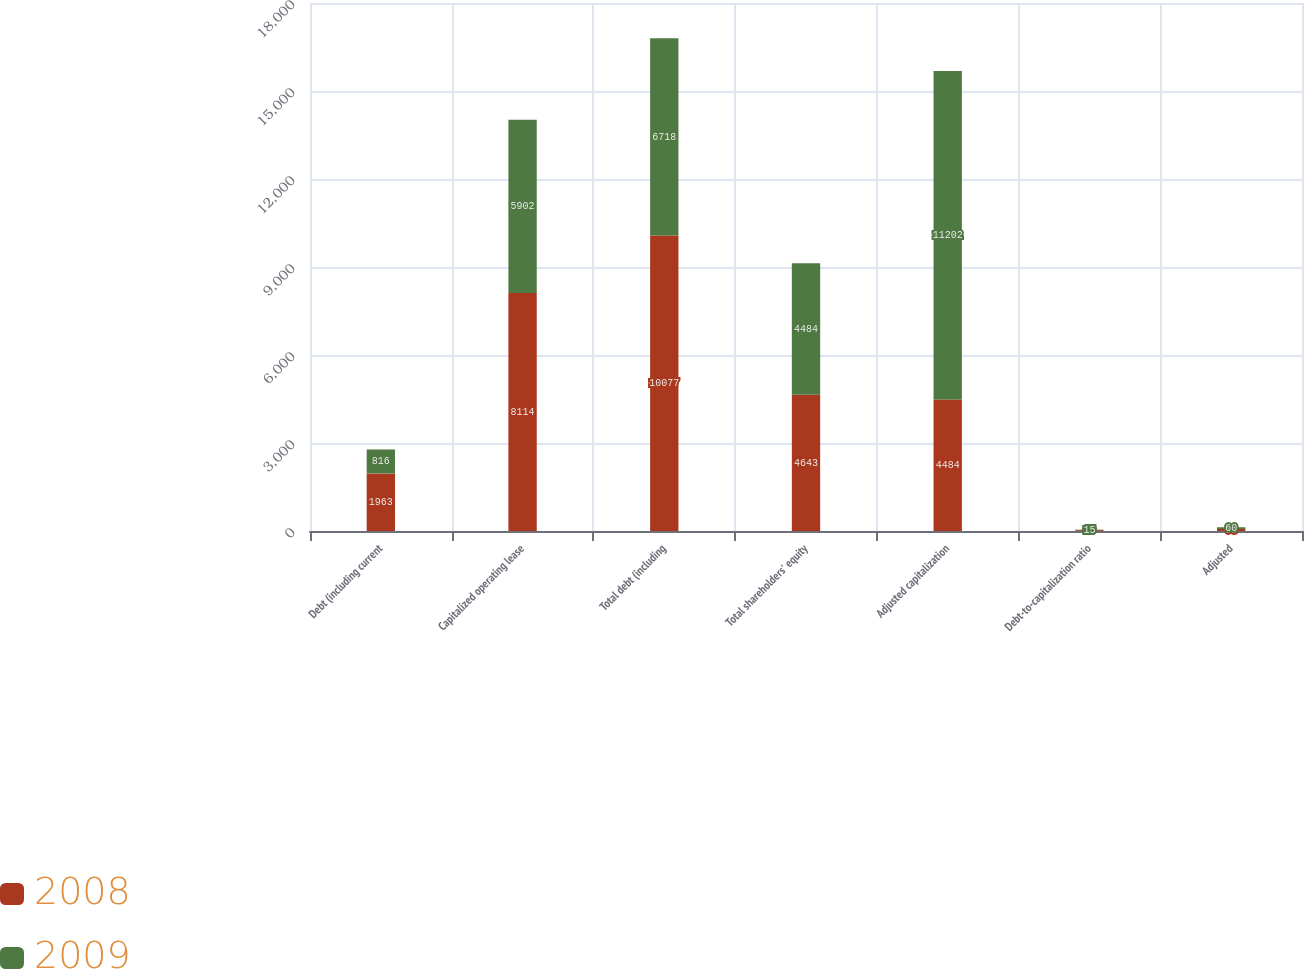Convert chart. <chart><loc_0><loc_0><loc_500><loc_500><stacked_bar_chart><ecel><fcel>Debt (including current<fcel>Capitalized operating lease<fcel>Total debt (including<fcel>Total shareholders' equity<fcel>Adjusted capitalization<fcel>Debt-to-capitalization ratio<fcel>Adjusted<nl><fcel>2008<fcel>1963<fcel>8114<fcel>10077<fcel>4643<fcel>4484<fcel>30<fcel>68<nl><fcel>2009<fcel>816<fcel>5902<fcel>6718<fcel>4484<fcel>11202<fcel>15<fcel>60<nl></chart> 